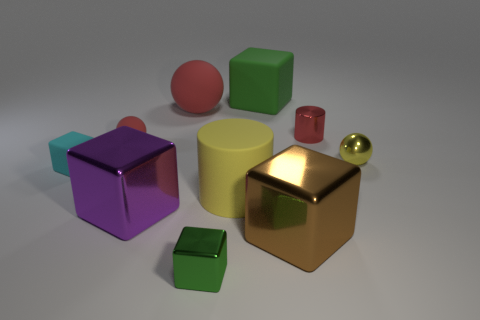Subtract all green cubes. How many were subtracted if there are1green cubes left? 1 Subtract all cylinders. How many objects are left? 8 Subtract 2 cylinders. How many cylinders are left? 0 Subtract all brown blocks. Subtract all red spheres. How many blocks are left? 4 Subtract all brown blocks. How many red balls are left? 2 Subtract all yellow metal spheres. Subtract all large brown rubber balls. How many objects are left? 9 Add 4 red metal cylinders. How many red metal cylinders are left? 5 Add 5 brown metallic objects. How many brown metallic objects exist? 6 Subtract all cyan cubes. How many cubes are left? 4 Subtract all cyan matte blocks. How many blocks are left? 4 